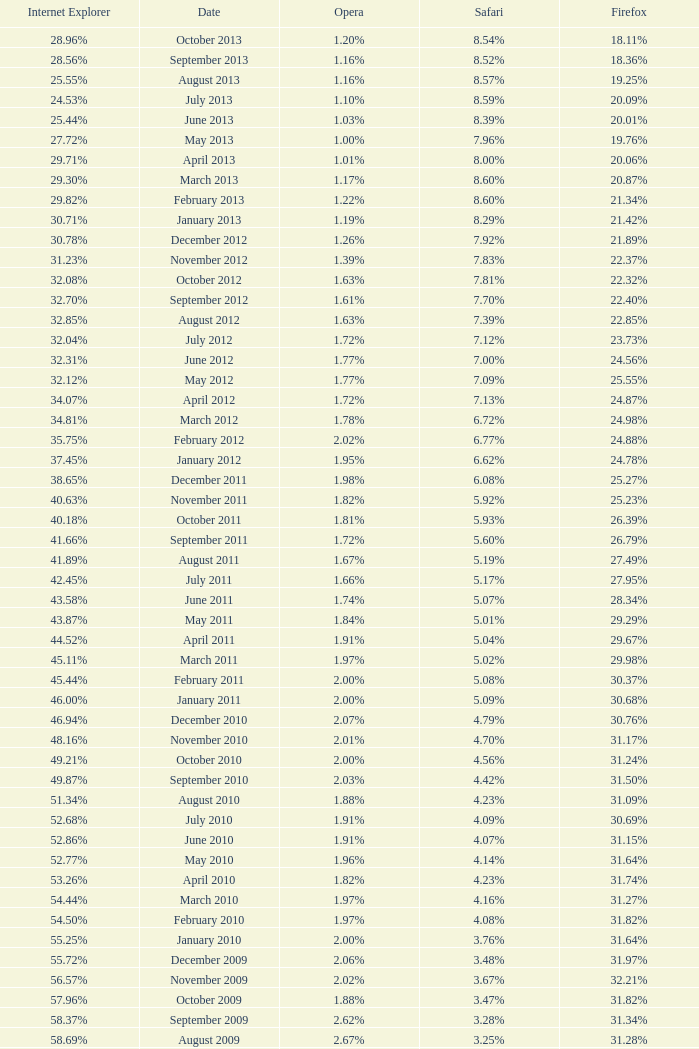What percentage of browsers were using Internet Explorer during the period in which 27.85% were using Firefox? 64.43%. 